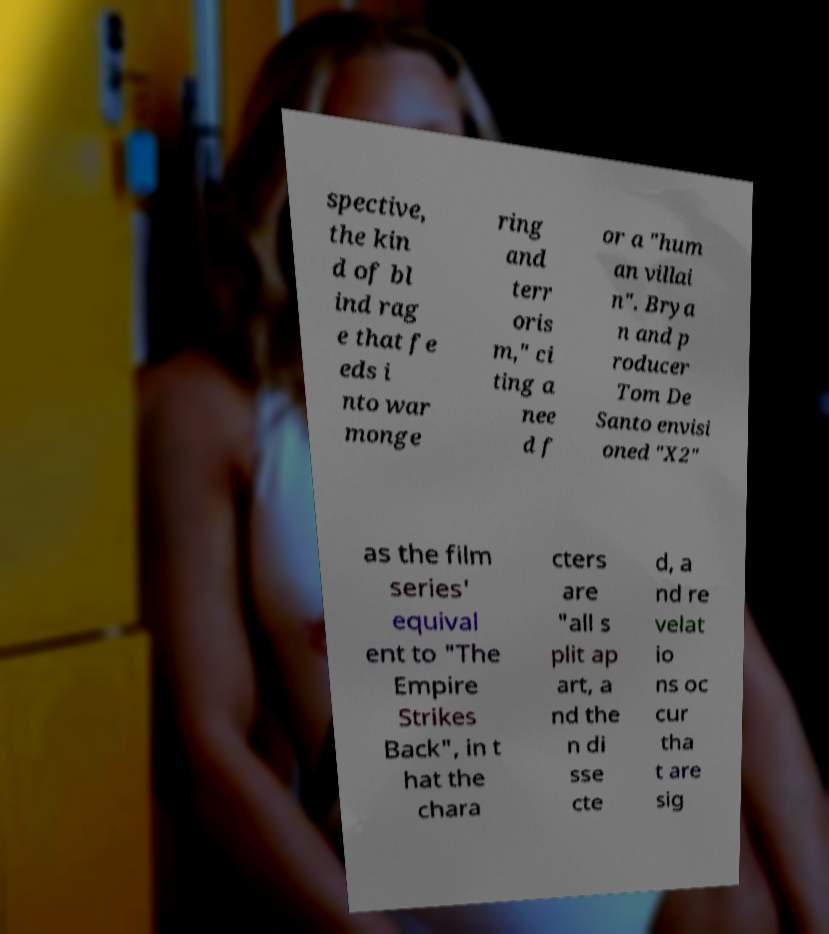Please identify and transcribe the text found in this image. spective, the kin d of bl ind rag e that fe eds i nto war monge ring and terr oris m," ci ting a nee d f or a "hum an villai n". Brya n and p roducer Tom De Santo envisi oned "X2" as the film series' equival ent to "The Empire Strikes Back", in t hat the chara cters are "all s plit ap art, a nd the n di sse cte d, a nd re velat io ns oc cur tha t are sig 